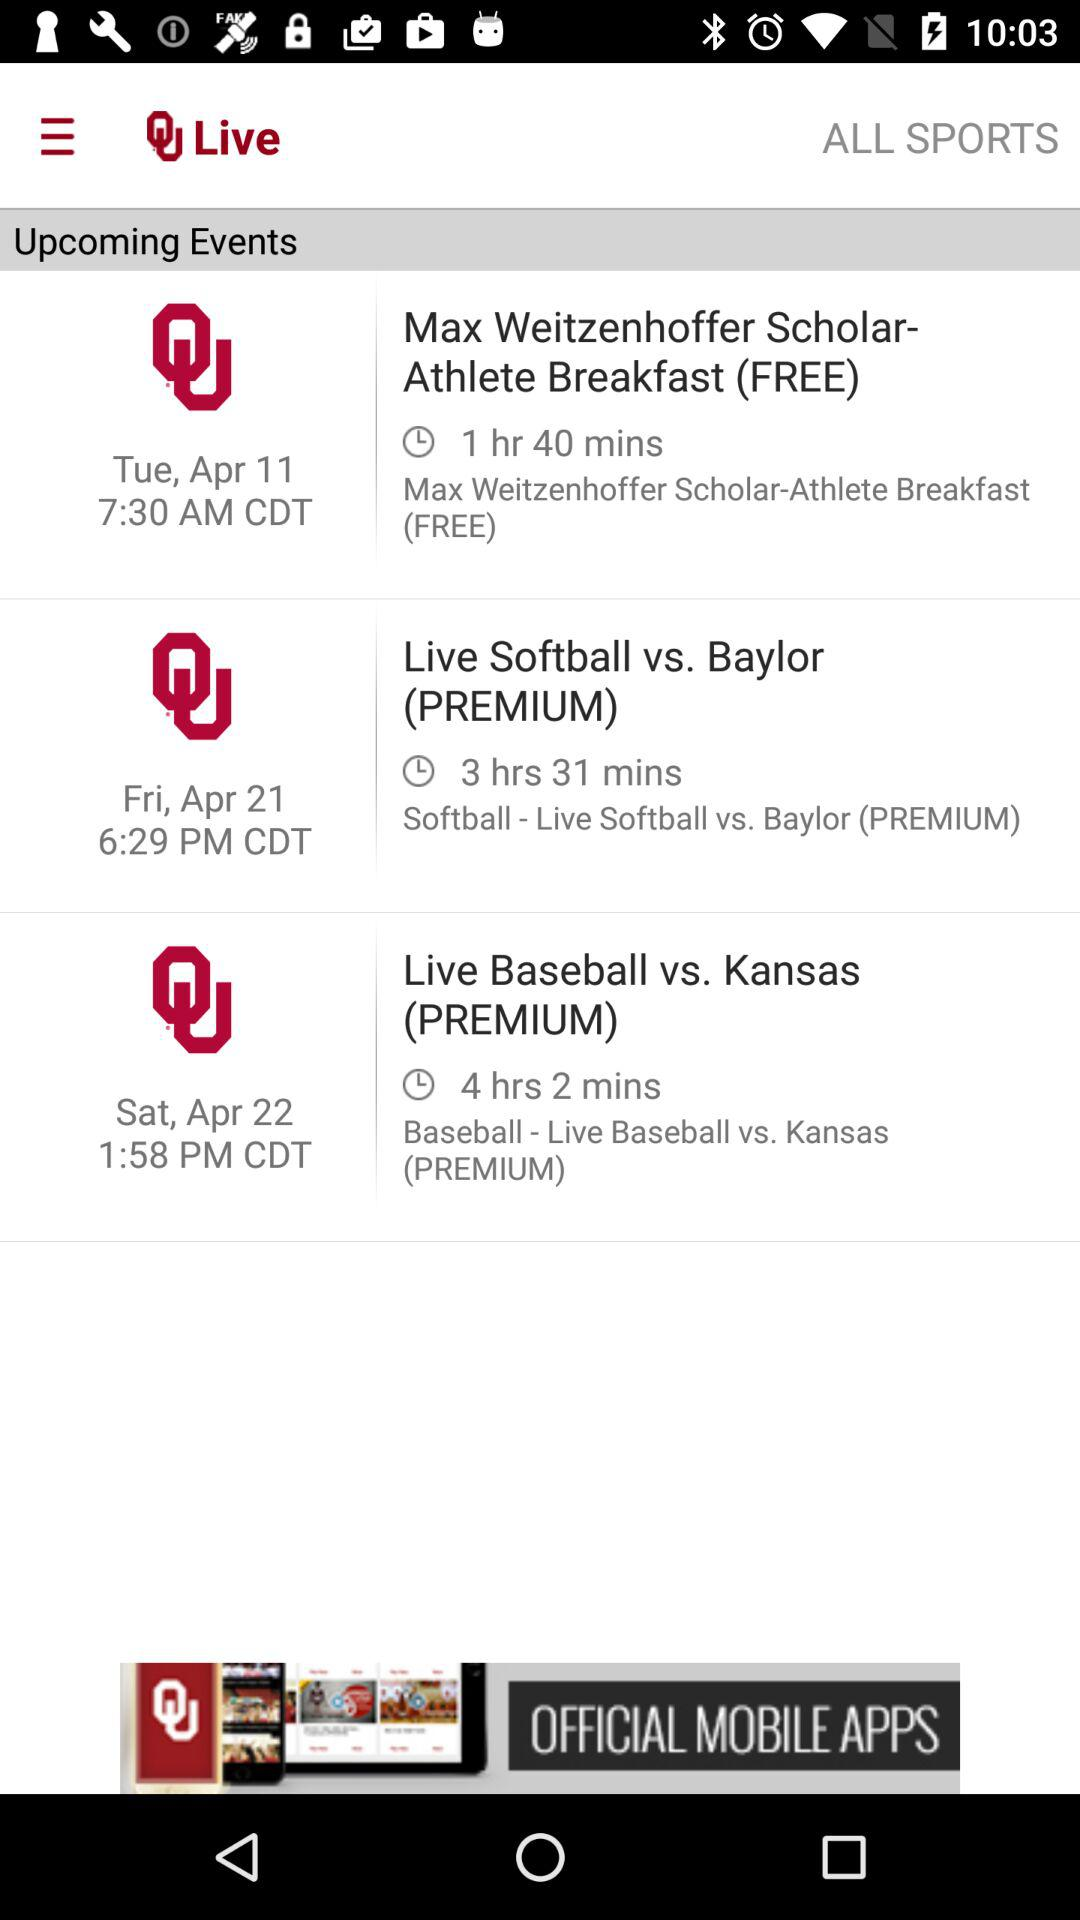What day is it on the scheduled date for the live event of "Softball vs. Baylor (PREMIUM)"? The day is Friday. 